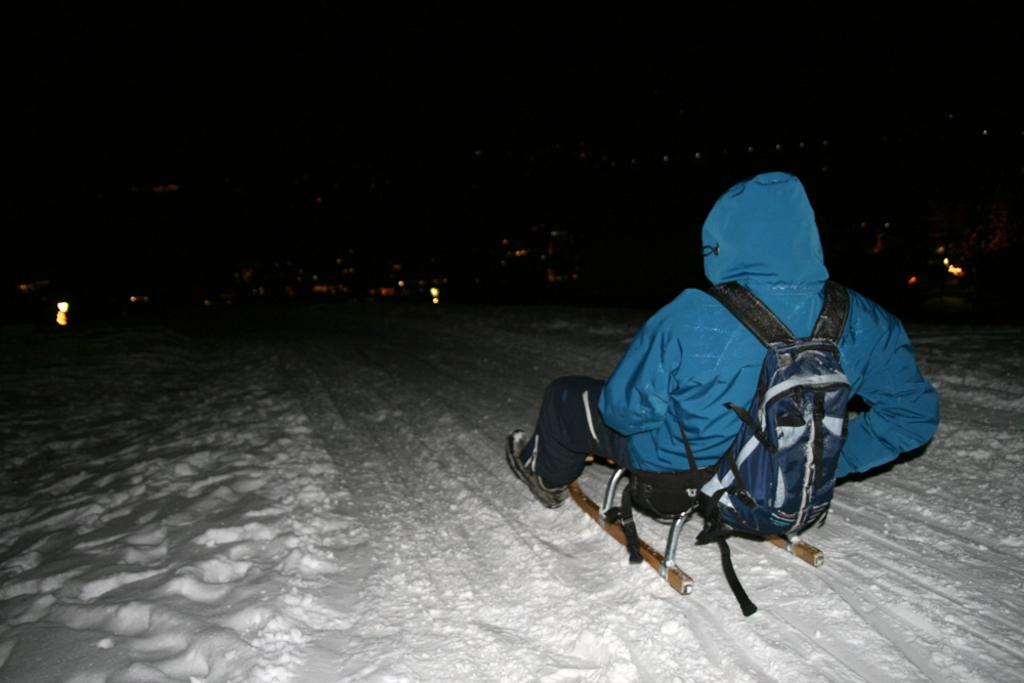Who or what is present in the image? There is a person in the image. What is the person wearing or carrying? The person is wearing a bag. What else can be seen in the image besides the person? There are sticks and lights visible in the image. How would you describe the overall appearance of the image? The background of the image appears to be dark. What type of comb is being used to eat dinner in the image? There is no comb or dinner present in the image; it features a person wearing a bag, sticks, and lights. What station is the person tuning into in the image? There is no reference to a station or any activity related to tuning in the image. 